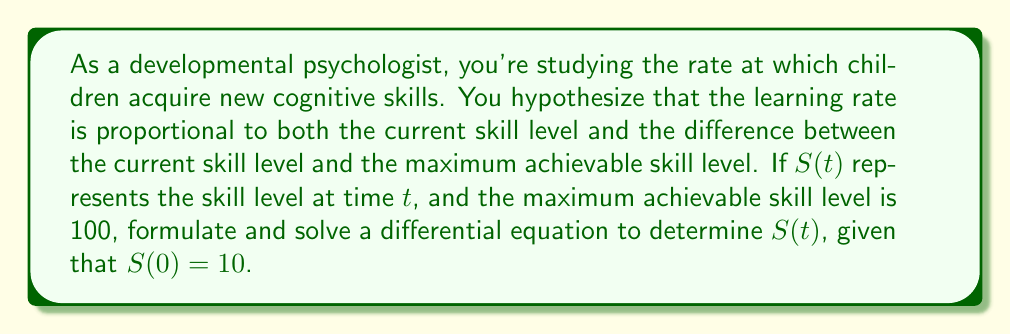Can you answer this question? Let's approach this step-by-step:

1) Based on the hypothesis, we can formulate the differential equation:

   $$\frac{dS}{dt} = kS(100-S)$$

   where $k$ is a positive constant representing the learning rate factor.

2) This is a separable differential equation. Let's separate the variables:

   $$\frac{dS}{S(100-S)} = k dt$$

3) Integrate both sides:

   $$\int \frac{dS}{S(100-S)} = \int k dt$$

4) The left side can be integrated using partial fractions:

   $$\int \left(\frac{1}{100S} + \frac{1}{100(100-S)}\right) dS = kt + C$$

5) Evaluating the integral:

   $$\frac{1}{100}\ln|S| - \frac{1}{100}\ln|100-S| = kt + C$$

6) Simplify:

   $$\ln\left|\frac{S}{100-S}\right| = 100kt + C$$

7) Take the exponential of both sides:

   $$\frac{S}{100-S} = Ae^{100kt}$$

   where $A = e^C$

8) Solve for $S$:

   $$S = \frac{100Ae^{100kt}}{1 + Ae^{100kt}}$$

9) Use the initial condition $S(0) = 10$ to find $A$:

   $$10 = \frac{100A}{1 + A}$$

   Solving this, we get $A = \frac{1}{9}$

10) Therefore, the final solution is:

    $$S(t) = \frac{100(\frac{1}{9}e^{100kt})}{1 + \frac{1}{9}e^{100kt}} = \frac{100}{9e^{-100kt} + 1}$$

This function is known as the logistic function, which is often used to model learning curves in psychology.
Answer: $$S(t) = \frac{100}{9e^{-100kt} + 1}$$ 